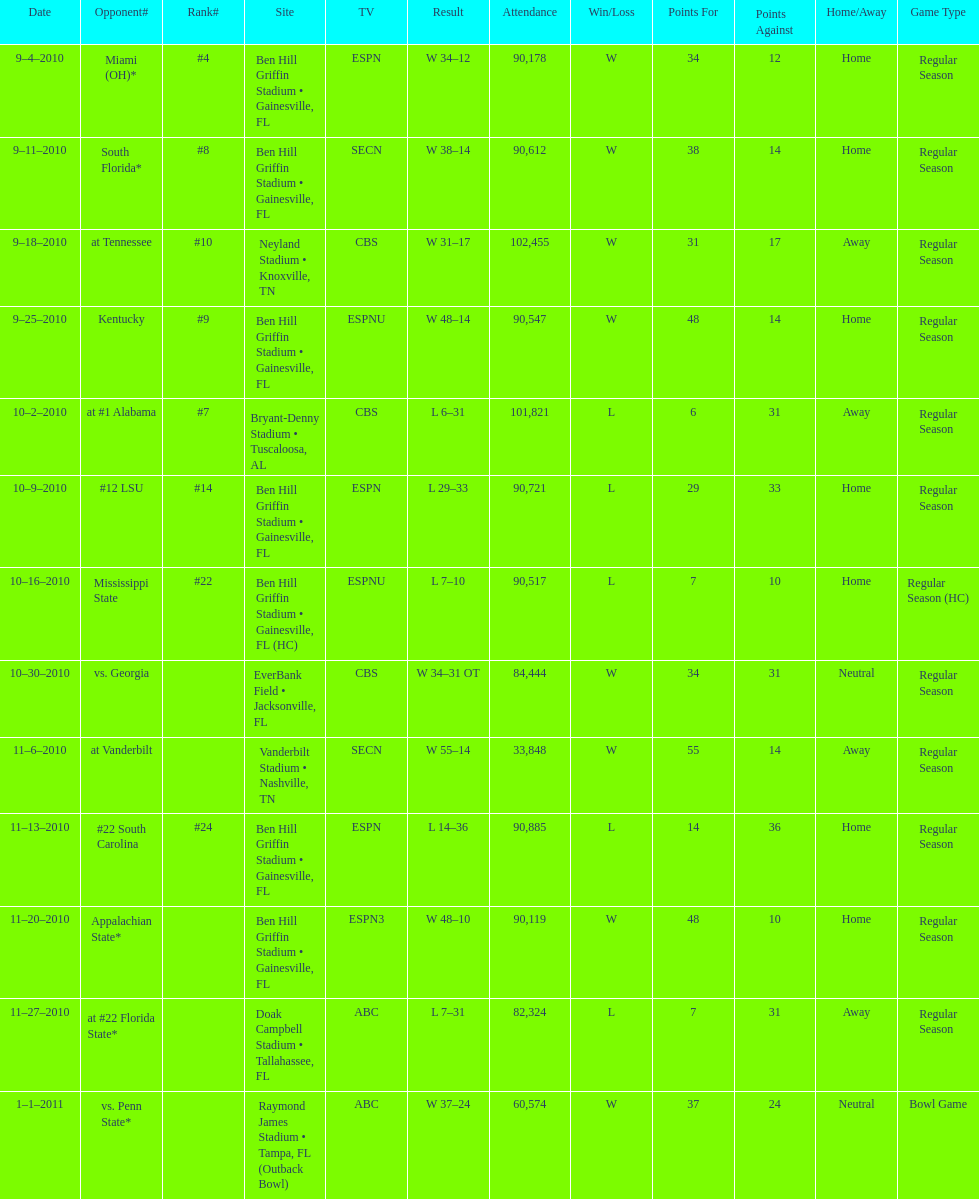How many games were played at the ben hill griffin stadium during the 2010-2011 season? 7. 